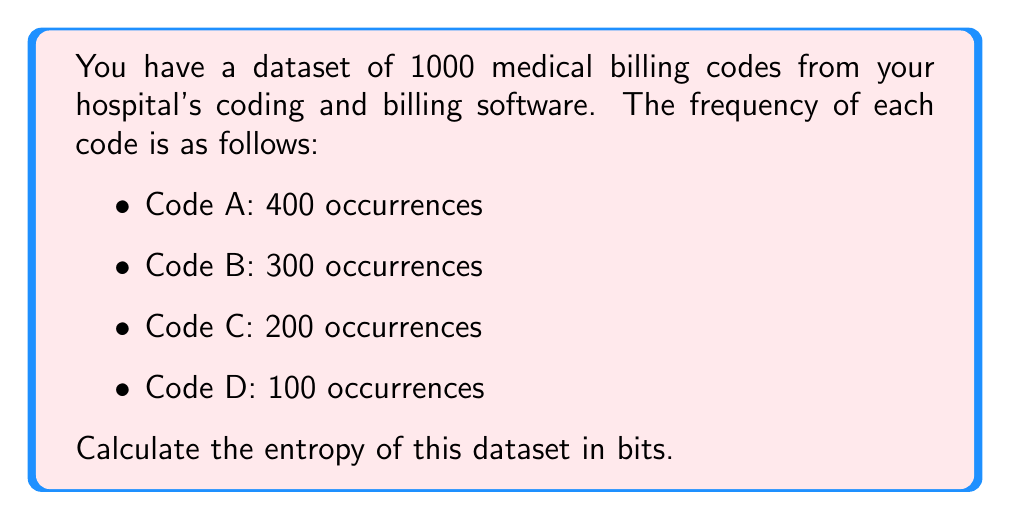Can you solve this math problem? To calculate the entropy of the dataset, we'll use the formula:

$$H = -\sum_{i=1}^{n} p_i \log_2(p_i)$$

Where:
- $H$ is the entropy
- $p_i$ is the probability of occurrence for each code
- $n$ is the number of unique codes

Step 1: Calculate the probabilities for each code
- $p_A = 400/1000 = 0.4$
- $p_B = 300/1000 = 0.3$
- $p_C = 200/1000 = 0.2$
- $p_D = 100/1000 = 0.1$

Step 2: Calculate each term of the sum
- For Code A: $-0.4 \log_2(0.4) = 0.528321$
- For Code B: $-0.3 \log_2(0.3) = 0.521026$
- For Code C: $-0.2 \log_2(0.2) = 0.464386$
- For Code D: $-0.1 \log_2(0.1) = 0.332193$

Step 3: Sum all terms
$$H = 0.528321 + 0.521026 + 0.464386 + 0.332193 = 1.845926$$

Therefore, the entropy of the dataset is approximately 1.845926 bits.
Answer: 1.846 bits (rounded to three decimal places) 